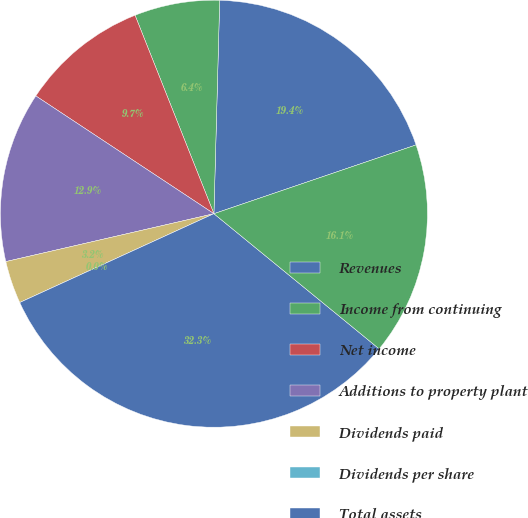Convert chart to OTSL. <chart><loc_0><loc_0><loc_500><loc_500><pie_chart><fcel>Revenues<fcel>Income from continuing<fcel>Net income<fcel>Additions to property plant<fcel>Dividends paid<fcel>Dividends per share<fcel>Total assets<fcel>Total long-term debt including<nl><fcel>19.35%<fcel>6.45%<fcel>9.68%<fcel>12.9%<fcel>3.23%<fcel>0.0%<fcel>32.26%<fcel>16.13%<nl></chart> 